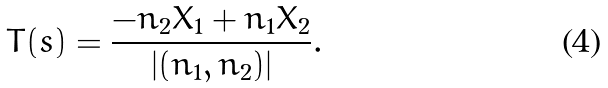<formula> <loc_0><loc_0><loc_500><loc_500>T ( s ) = \frac { - n _ { 2 } X _ { 1 } + n _ { 1 } X _ { 2 } } { | ( n _ { 1 } , n _ { 2 } ) | } .</formula> 